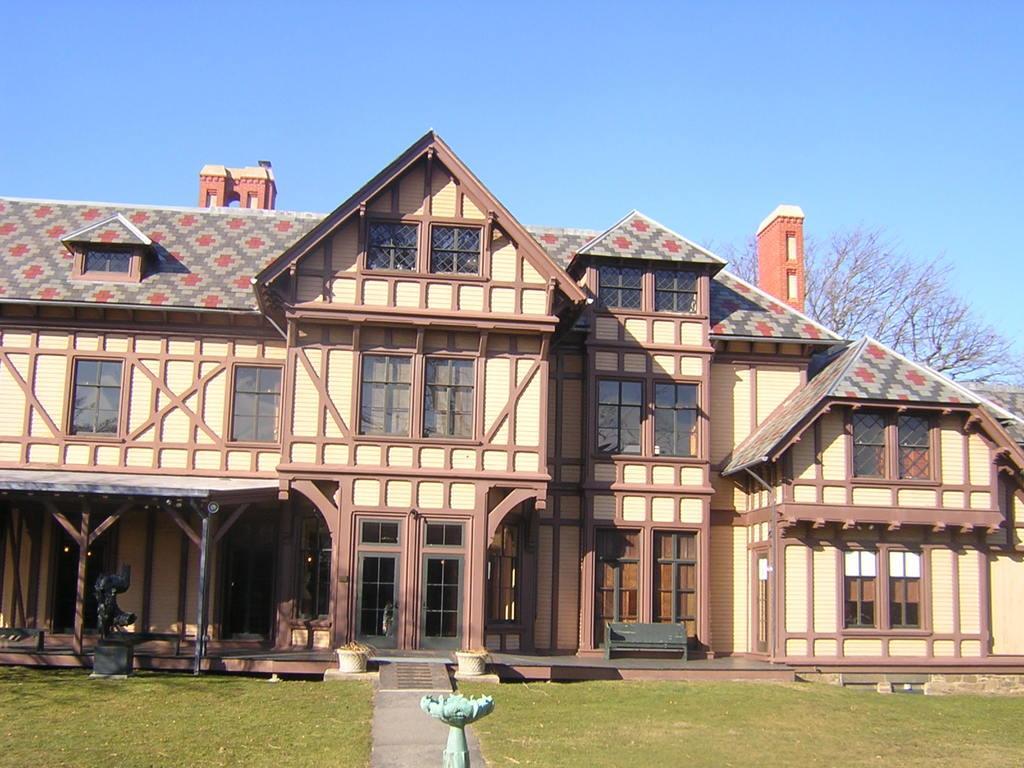Can you describe this image briefly? In this image, we can see green grass on the ground, there is a building and in the background at right side there is a tree, at the top there is a blue color sky. 